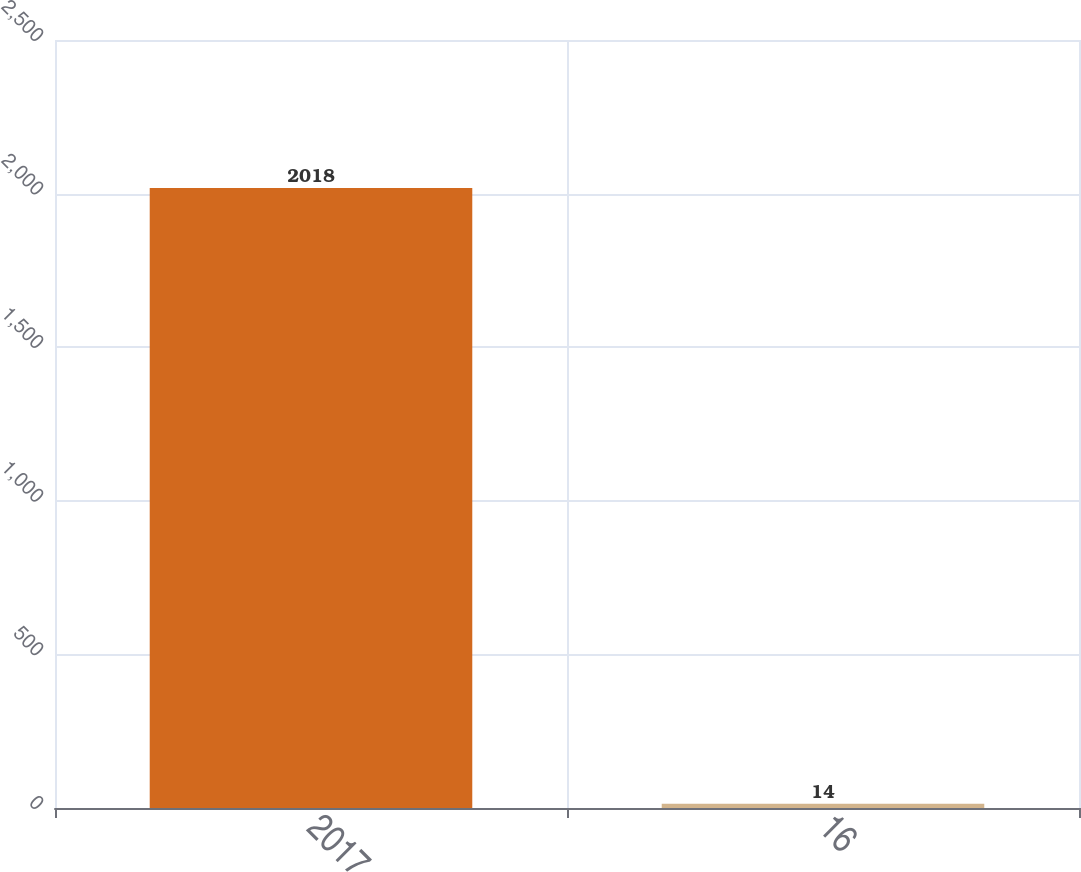Convert chart. <chart><loc_0><loc_0><loc_500><loc_500><bar_chart><fcel>2017<fcel>16<nl><fcel>2018<fcel>14<nl></chart> 